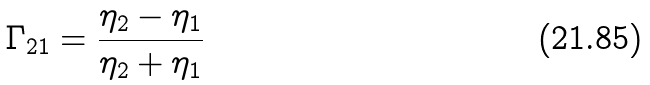Convert formula to latex. <formula><loc_0><loc_0><loc_500><loc_500>\Gamma _ { 2 1 } = \frac { \eta _ { 2 } - \eta _ { 1 } } { \eta _ { 2 } + \eta _ { 1 } }</formula> 